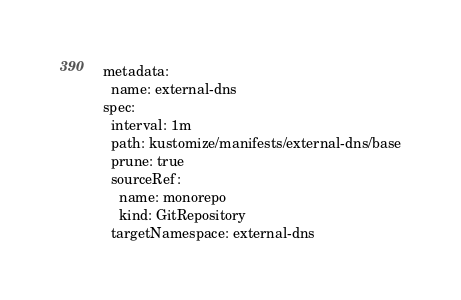Convert code to text. <code><loc_0><loc_0><loc_500><loc_500><_YAML_>metadata:
  name: external-dns
spec:
  interval: 1m
  path: kustomize/manifests/external-dns/base
  prune: true
  sourceRef:
    name: monorepo
    kind: GitRepository
  targetNamespace: external-dns
</code> 